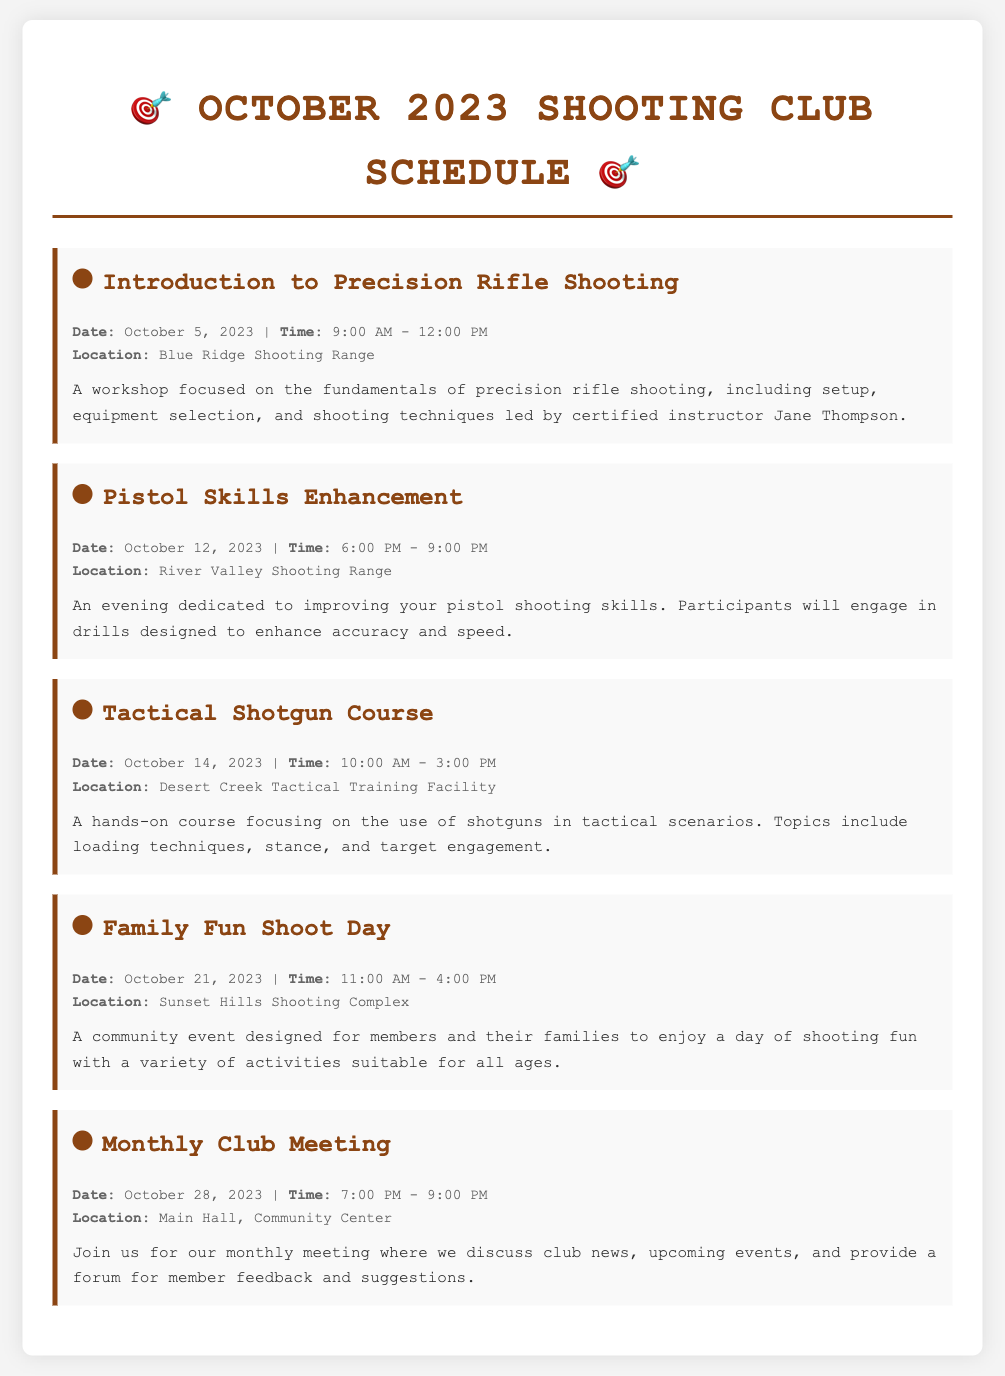What is the date of the Introduction to Precision Rifle Shooting event? The date is specifically mentioned in the event details section of the document.
Answer: October 5, 2023 What time does the Pistol Skills Enhancement event start? The start time is provided in the event details section for the Pistol Skills Enhancement event.
Answer: 6:00 PM Where will the Tactical Shotgun Course take place? The location is explicitly stated in the event details for the Tactical Shotgun Course.
Answer: Desert Creek Tactical Training Facility How long is the Family Fun Shoot Day event scheduled for? The duration can be inferred from the start and end times provided in the event details for the Family Fun Shoot Day.
Answer: 5 hours What is the focus of the Introduction to Precision Rifle Shooting workshop? The focus is described in the event description of the Introduction to Precision Rifle Shooting event.
Answer: Fundamentals of precision rifle shooting Which event is scheduled for October 28, 2023? The event is mentioned along with its details in the menu, specifically on that date.
Answer: Monthly Club Meeting What is the main purpose of the Monthly Club Meeting? The purpose is outlined in the event description of the Monthly Club Meeting in the document.
Answer: Discuss club news and member feedback On which date will the Family Fun Shoot Day occur? The specific date is mentioned in the event details associated with the Family Fun Shoot Day.
Answer: October 21, 2023 